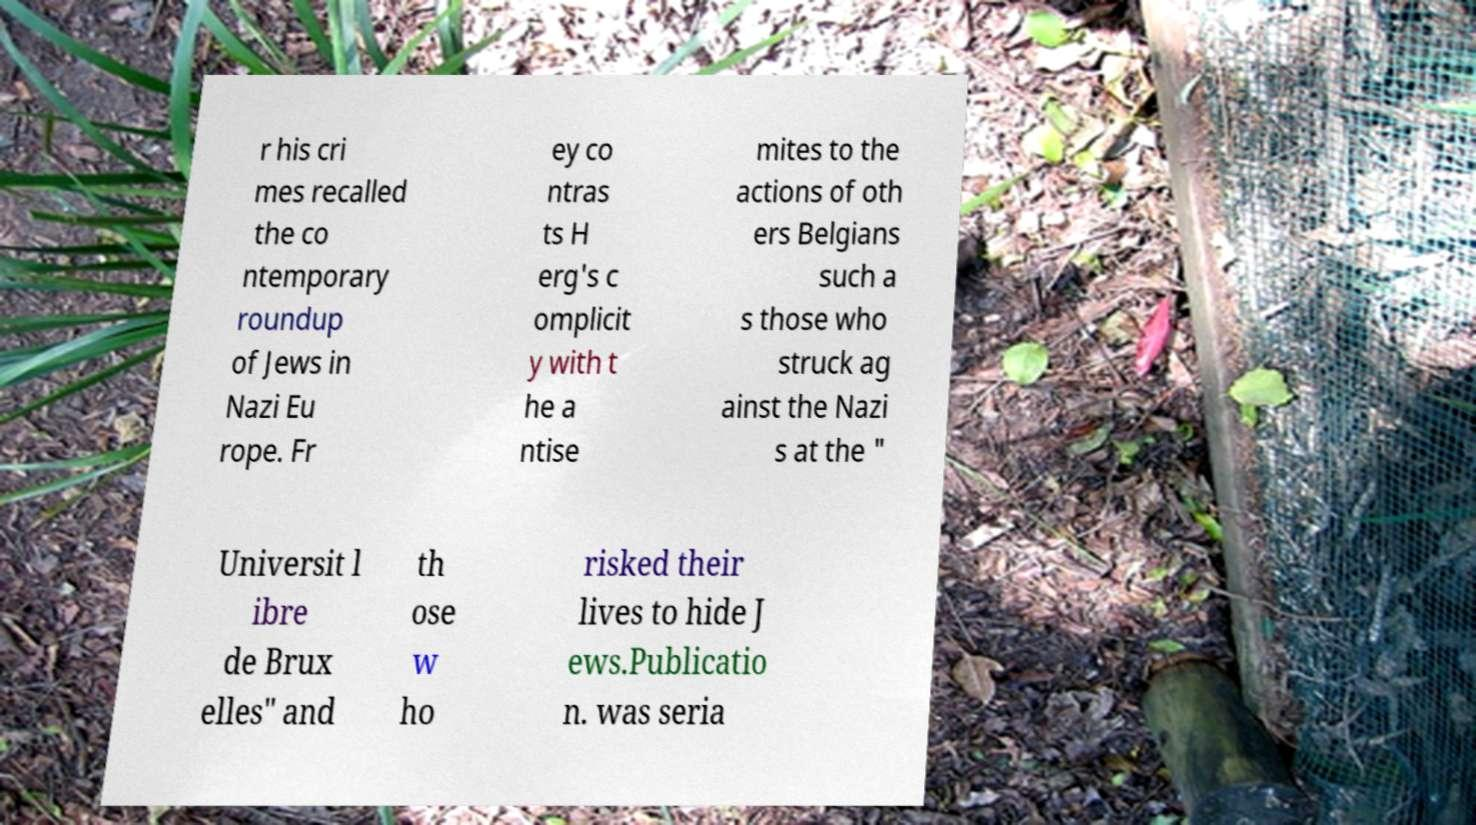Could you extract and type out the text from this image? r his cri mes recalled the co ntemporary roundup of Jews in Nazi Eu rope. Fr ey co ntras ts H erg's c omplicit y with t he a ntise mites to the actions of oth ers Belgians such a s those who struck ag ainst the Nazi s at the " Universit l ibre de Brux elles" and th ose w ho risked their lives to hide J ews.Publicatio n. was seria 